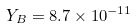Convert formula to latex. <formula><loc_0><loc_0><loc_500><loc_500>Y _ { B } = 8 . 7 \times 1 0 ^ { - 1 1 }</formula> 